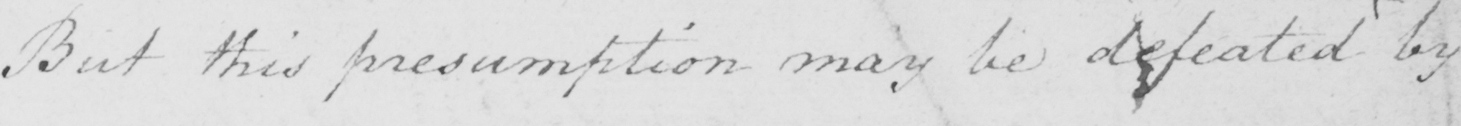Please provide the text content of this handwritten line. But this presumption may be defeated by 